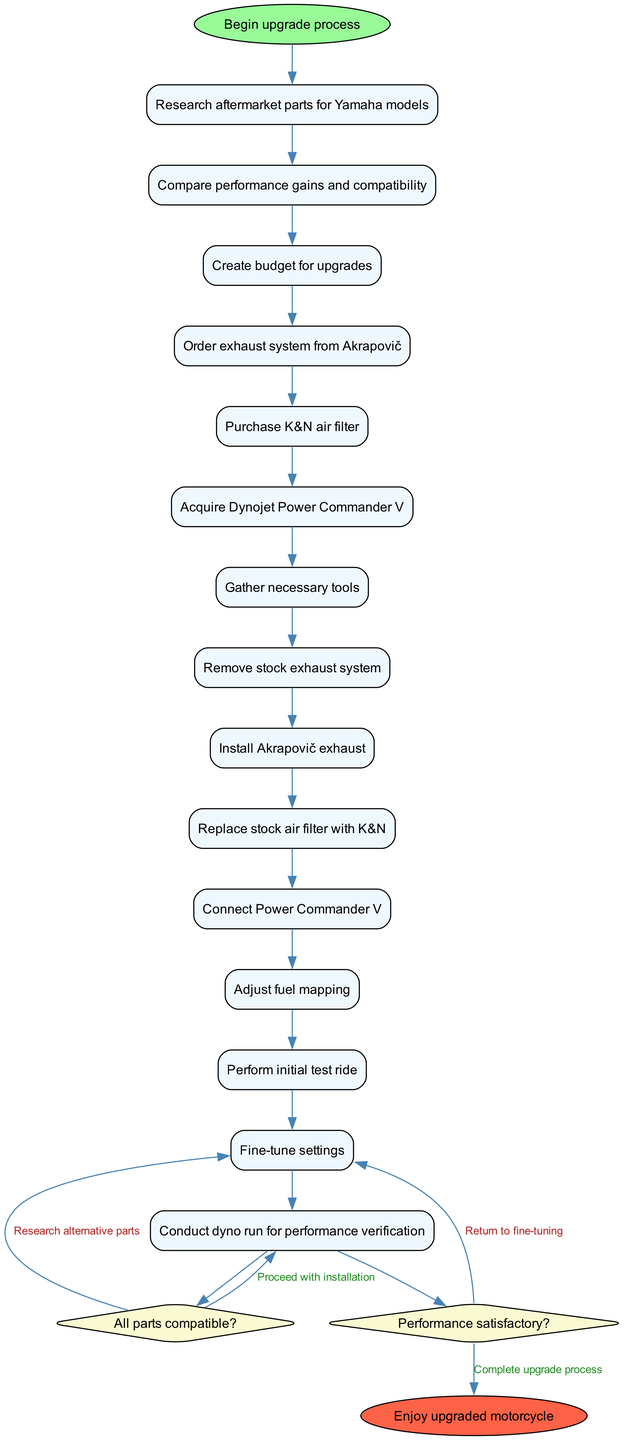What is the starting point of the upgrade process? The starting point of the upgrade process is indicated by the first node labeled "Begin upgrade process." This is shown as the initial activity before any further steps are taken.
Answer: Begin upgrade process How many activities are there in the diagram? By counting each unique activity listed in the activities section, we find there are a total of 15 activities involved in the upgrade process.
Answer: 15 What question is asked after the initial activities? The first decision node follows the last activity and poses the question "All parts compatible?" This is the first decision that impacts the flow of the process.
Answer: All parts compatible? What happens if the aftermarket parts are not compatible? If the answer to the question "All parts compatible?" is 'no', the flow directs back to research alternative parts, indicating that further investigation is needed to find suitable components before proceeding.
Answer: Research alternative parts What is the end point of the upgrade process? The final node in the diagram is labeled "Enjoy upgraded motorcycle," which signifies the completion of the entire upgrade process after testing and fine-tuning.
Answer: Enjoy upgraded motorcycle How is the flow from installation to testing structured? The flow from installation consists of connecting the Power Commander V, adjusting fuel mapping, and performing an initial test ride before fine-tuning and conducting a dyno run for performance verification. This sequence indicates the step-by-step order of the process.
Answer: Installation → Testing What follows if performance is not satisfactory? If the performance is deemed 'no' after testing, the flow returns to the fine-tuning step, suggesting that adjustments must be made until the performance reaches the desired level.
Answer: Return to fine-tuning How many decision points are there in the process? There are two decision points in the process, as indicated by the decision nodes questioning part compatibility and performance satisfaction, respectively.
Answer: 2 What is the purpose of conducting a dyno run? Conducting a dyno run serves the purpose of performance verification, allowing the user to confirm that the upgrades have had the desired impact on the motorcycle's performance metrics.
Answer: Performance verification 